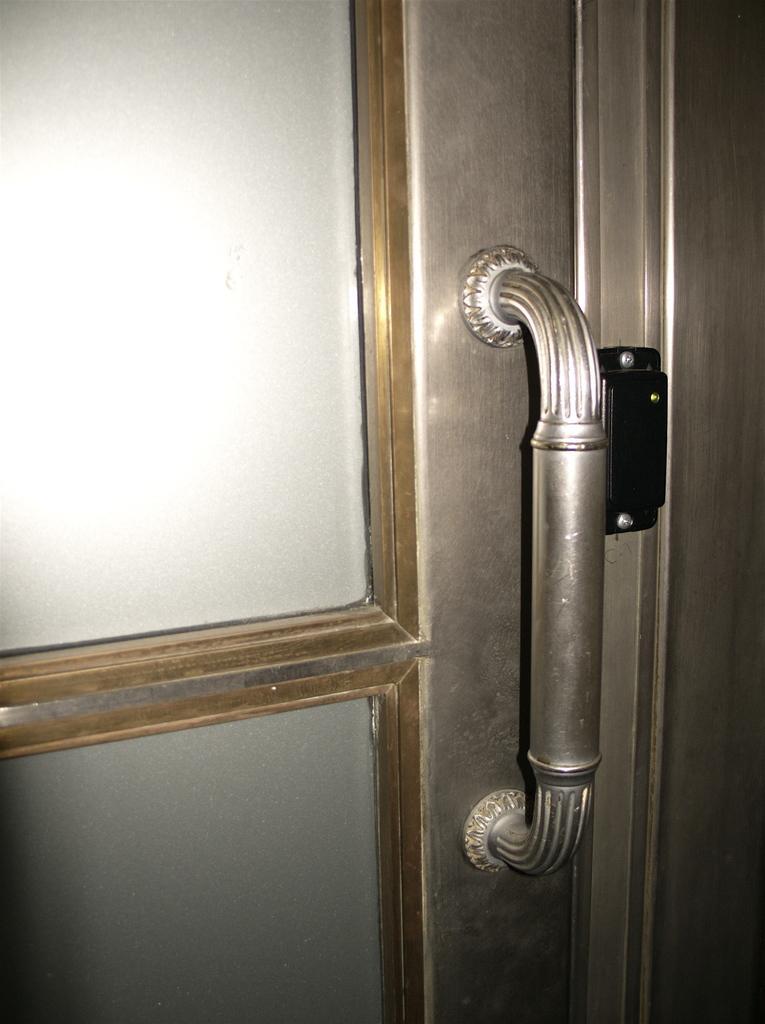How would you summarize this image in a sentence or two? In this image, we can see a door with the handle. We can also see a black colored object. 